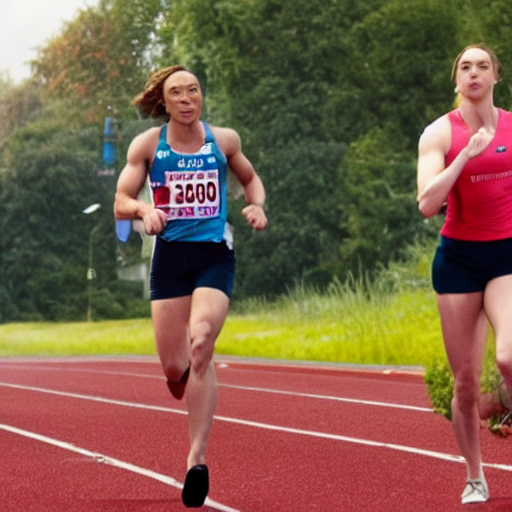What can you surmise about the weather and lighting conditions during this event? From the lighting in the photograph, it appears to be an overcast day. The diffuse light suggests either a thin cloud cover or a time of day when the sun isn't directly casting harsh shadows on the athletes, providing even lighting across the scene. There are no visible signs of precipitation or wet surfaces, indicating that while it might be a cloudy day, the conditions are dry. The athletes' attire also supports the idea of favorable, mild weather, conducive to outdoor sports. 